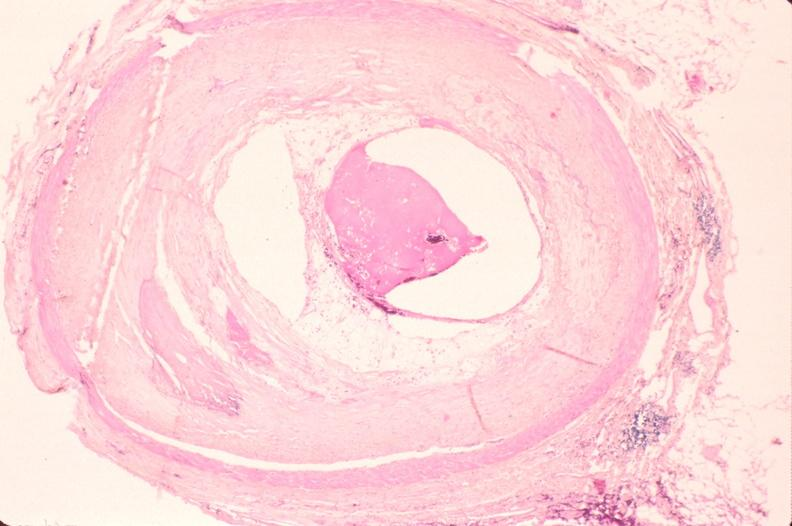s cardiovascular present?
Answer the question using a single word or phrase. Yes 